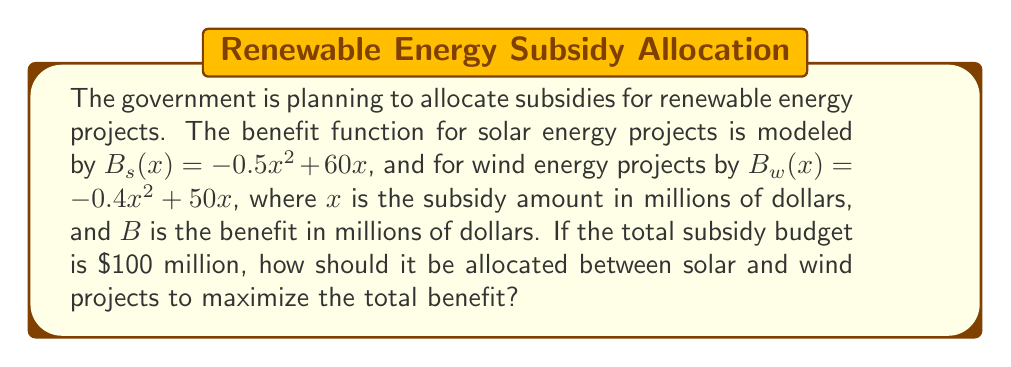Can you answer this question? 1. Let $x$ be the subsidy for solar and $(100-x)$ be the subsidy for wind.

2. The total benefit function is:
   $B(x) = B_s(x) + B_w(100-x)$
   $B(x) = (-0.5x^2 + 60x) + (-0.4(100-x)^2 + 50(100-x))$

3. Expand the equation:
   $B(x) = -0.5x^2 + 60x - 0.4(10000 - 200x + x^2) + 5000 - 50x$
   $B(x) = -0.5x^2 + 60x - 4000 + 80x - 0.4x^2 + 5000 - 50x$
   $B(x) = -0.9x^2 + 90x + 1000$

4. To find the maximum, differentiate and set to zero:
   $\frac{dB}{dx} = -1.8x + 90 = 0$

5. Solve for x:
   $-1.8x = -90$
   $x = 50$

6. Verify it's a maximum by checking the second derivative:
   $\frac{d^2B}{dx^2} = -1.8 < 0$, confirming a maximum.

7. Therefore, allocate $50 million to solar and $50 million to wind projects.
Answer: $50 million for solar, $50 million for wind 